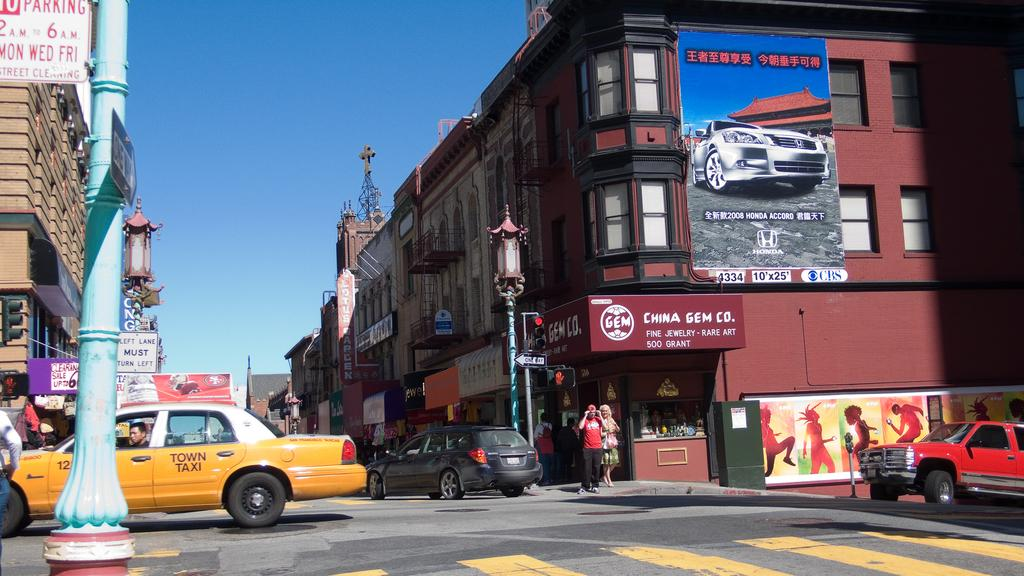<image>
Summarize the visual content of the image. A street scene with a store called China Gem Store visible 